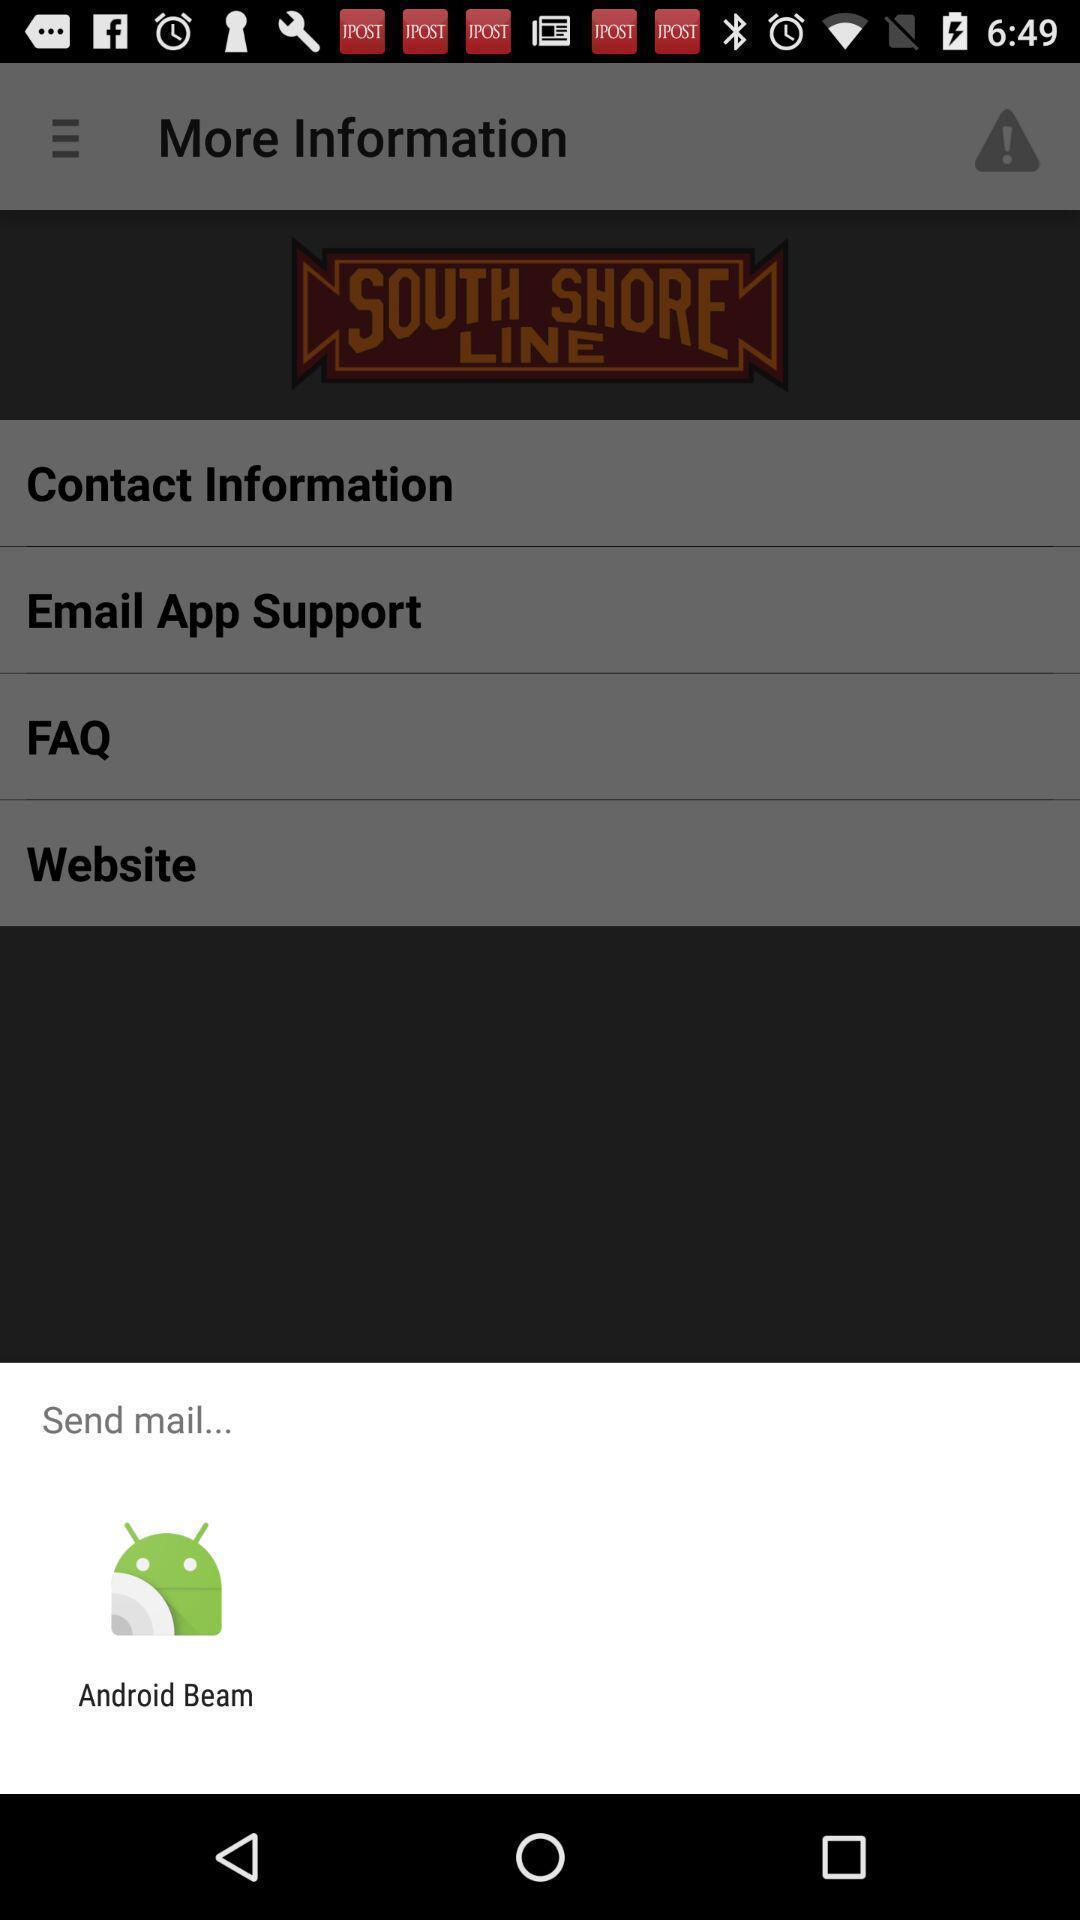Summarize the information in this screenshot. Popup to send mail in the application. 